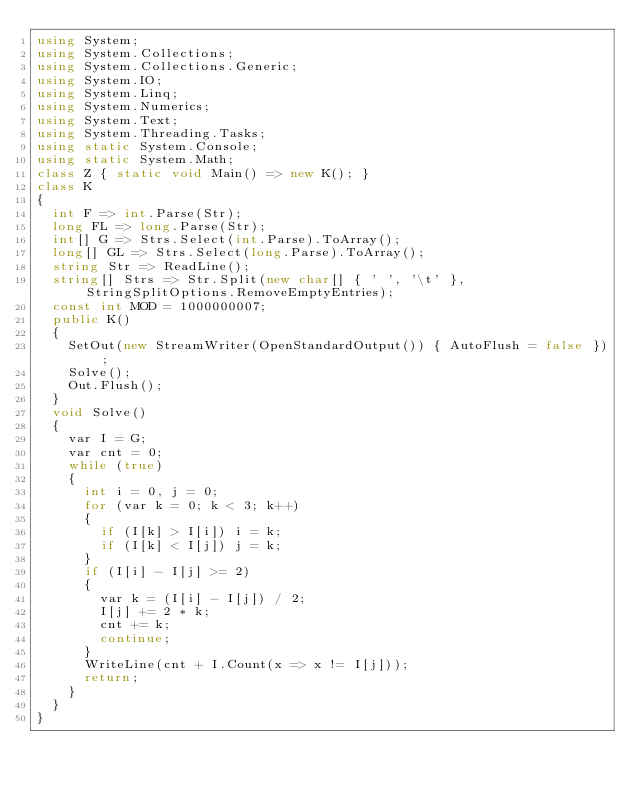<code> <loc_0><loc_0><loc_500><loc_500><_C#_>using System;
using System.Collections;
using System.Collections.Generic;
using System.IO;
using System.Linq;
using System.Numerics;
using System.Text;
using System.Threading.Tasks;
using static System.Console;
using static System.Math;
class Z { static void Main() => new K(); }
class K
{
	int F => int.Parse(Str);
	long FL => long.Parse(Str);
	int[] G => Strs.Select(int.Parse).ToArray();
	long[] GL => Strs.Select(long.Parse).ToArray();
	string Str => ReadLine();
	string[] Strs => Str.Split(new char[] { ' ', '\t' }, StringSplitOptions.RemoveEmptyEntries);
	const int MOD = 1000000007;
	public K()
	{
		SetOut(new StreamWriter(OpenStandardOutput()) { AutoFlush = false });
		Solve();
		Out.Flush();
	}
	void Solve()
	{
		var I = G;
		var cnt = 0;
		while (true)
		{
			int i = 0, j = 0;
			for (var k = 0; k < 3; k++)
			{
				if (I[k] > I[i]) i = k;
				if (I[k] < I[j]) j = k;
			}
			if (I[i] - I[j] >= 2)
			{
				var k = (I[i] - I[j]) / 2;
				I[j] += 2 * k;
				cnt += k;
				continue;
			}
			WriteLine(cnt + I.Count(x => x != I[j]));
			return;
		}
	}
}
</code> 